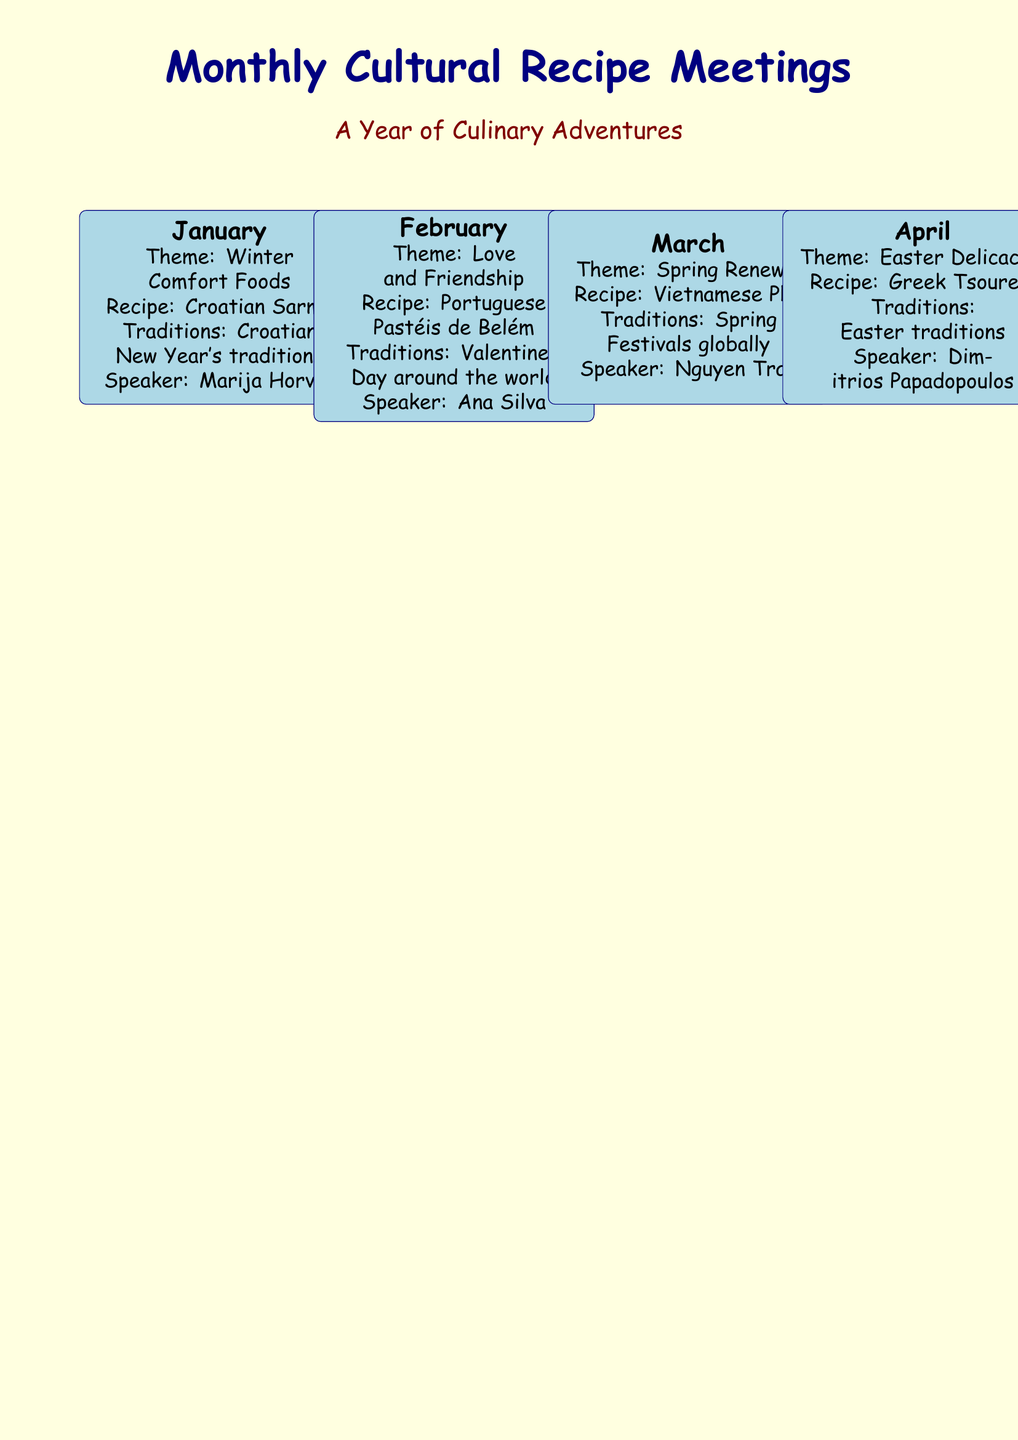What is the theme for January? The theme for January is listed alongside the recipe and traditions, showing the focus for that month's meeting.
Answer: Winter Comfort Foods Who is the speaker for the March meeting? The document identifies each month’s speaker, providing insight into who will be presenting.
Answer: Nguyen Tran What recipe will be discussed in October? Each month includes a specific recipe that is a part of the meeting's theme and traditions.
Answer: Mexican Pan de Muerto Which month features German Stollen? The document organizes activities by month, allowing easy identification of which traditions correspond with each recipe.
Answer: December How many meetings focus on holiday-related traditions? By analyzing the document, one can see the number of festive months with themes related to holidays.
Answer: 3 What is the recipe for the August meeting? Each month presents a specific recipe, showing culinary diversity throughout the year.
Answer: Indian Biryani In which month is the theme "Thanksgiving Traditions"? The document segments each month, allowing clear identification of holiday-specific themes.
Answer: November Which country's dish is featured in the June meeting? Details about the dish and its origin country are provided for each meeting to enhance cultural understanding.
Answer: South Africa What culinary theme is presented in May? Each month has a designated culinary theme, allowing participants to prepare for the specific focus of the meeting.
Answer: Mediterranean Diet 